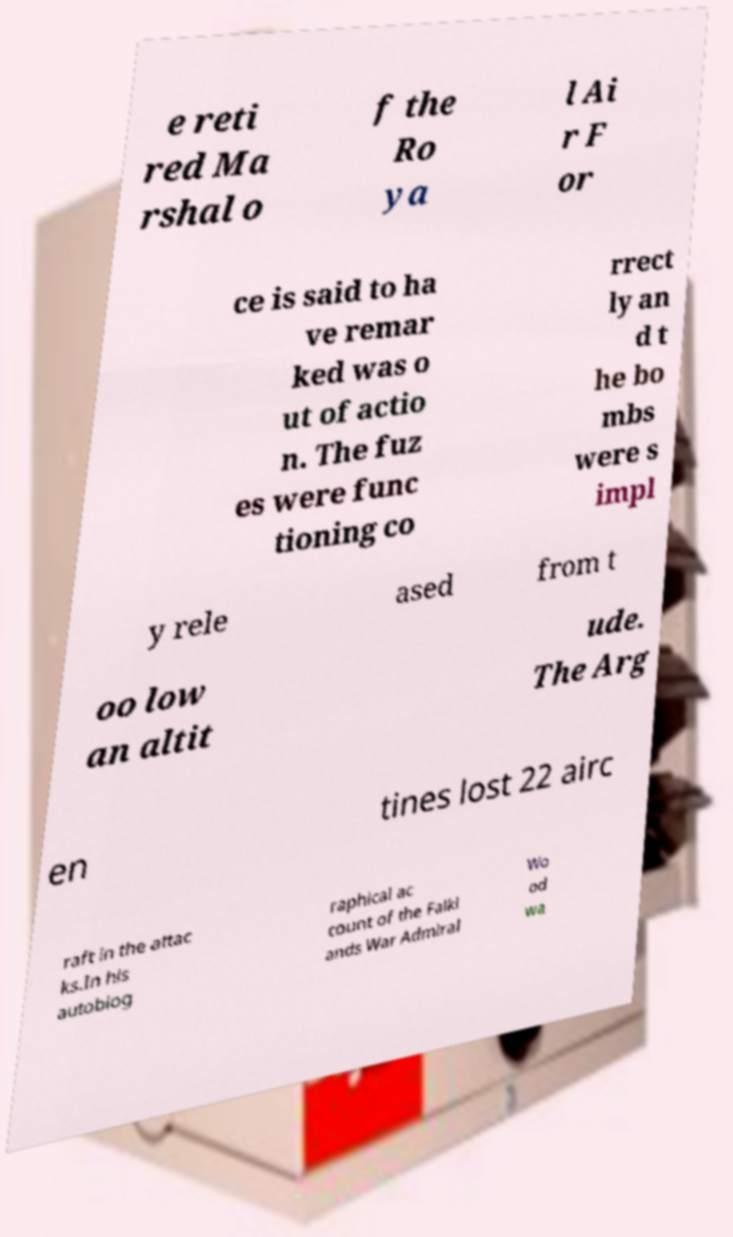Can you read and provide the text displayed in the image?This photo seems to have some interesting text. Can you extract and type it out for me? e reti red Ma rshal o f the Ro ya l Ai r F or ce is said to ha ve remar ked was o ut of actio n. The fuz es were func tioning co rrect ly an d t he bo mbs were s impl y rele ased from t oo low an altit ude. The Arg en tines lost 22 airc raft in the attac ks.In his autobiog raphical ac count of the Falkl ands War Admiral Wo od wa 